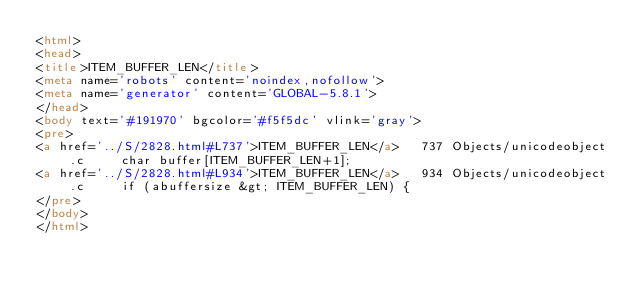<code> <loc_0><loc_0><loc_500><loc_500><_HTML_><html>
<head>
<title>ITEM_BUFFER_LEN</title>
<meta name='robots' content='noindex,nofollow'>
<meta name='generator' content='GLOBAL-5.8.1'>
</head>
<body text='#191970' bgcolor='#f5f5dc' vlink='gray'>
<pre>
<a href='../S/2828.html#L737'>ITEM_BUFFER_LEN</a>   737 Objects/unicodeobject.c     char buffer[ITEM_BUFFER_LEN+1];
<a href='../S/2828.html#L934'>ITEM_BUFFER_LEN</a>   934 Objects/unicodeobject.c     if (abuffersize &gt; ITEM_BUFFER_LEN) {
</pre>
</body>
</html>
</code> 